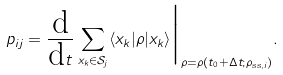Convert formula to latex. <formula><loc_0><loc_0><loc_500><loc_500>p _ { i j } = \frac { \text {d} } { \text {d} t } \sum _ { x _ { k } \in \mathcal { S } _ { j } } \langle x _ { k } | \rho | x _ { k } \rangle \Big | _ { \rho = \rho ( t _ { 0 } + \Delta t ; \rho _ { \text {ss} , i } ) } .</formula> 